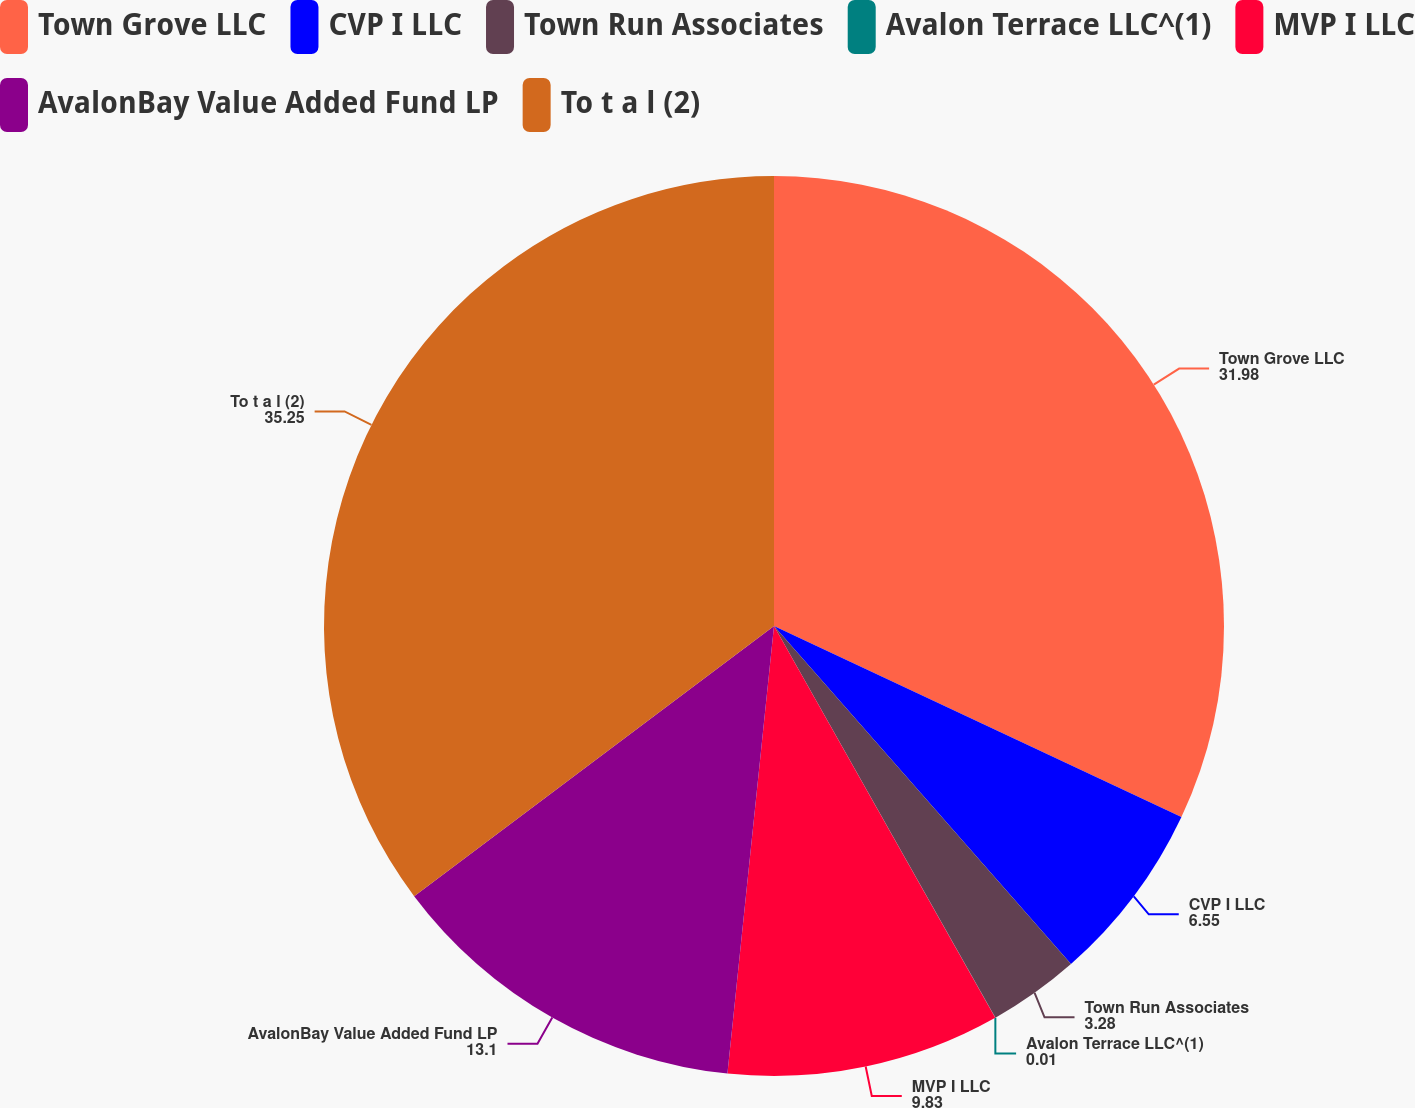Convert chart to OTSL. <chart><loc_0><loc_0><loc_500><loc_500><pie_chart><fcel>Town Grove LLC<fcel>CVP I LLC<fcel>Town Run Associates<fcel>Avalon Terrace LLC^(1)<fcel>MVP I LLC<fcel>AvalonBay Value Added Fund LP<fcel>To t a l (2)<nl><fcel>31.98%<fcel>6.55%<fcel>3.28%<fcel>0.01%<fcel>9.83%<fcel>13.1%<fcel>35.25%<nl></chart> 